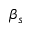Convert formula to latex. <formula><loc_0><loc_0><loc_500><loc_500>\beta _ { s }</formula> 